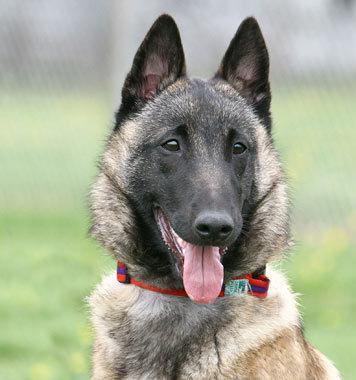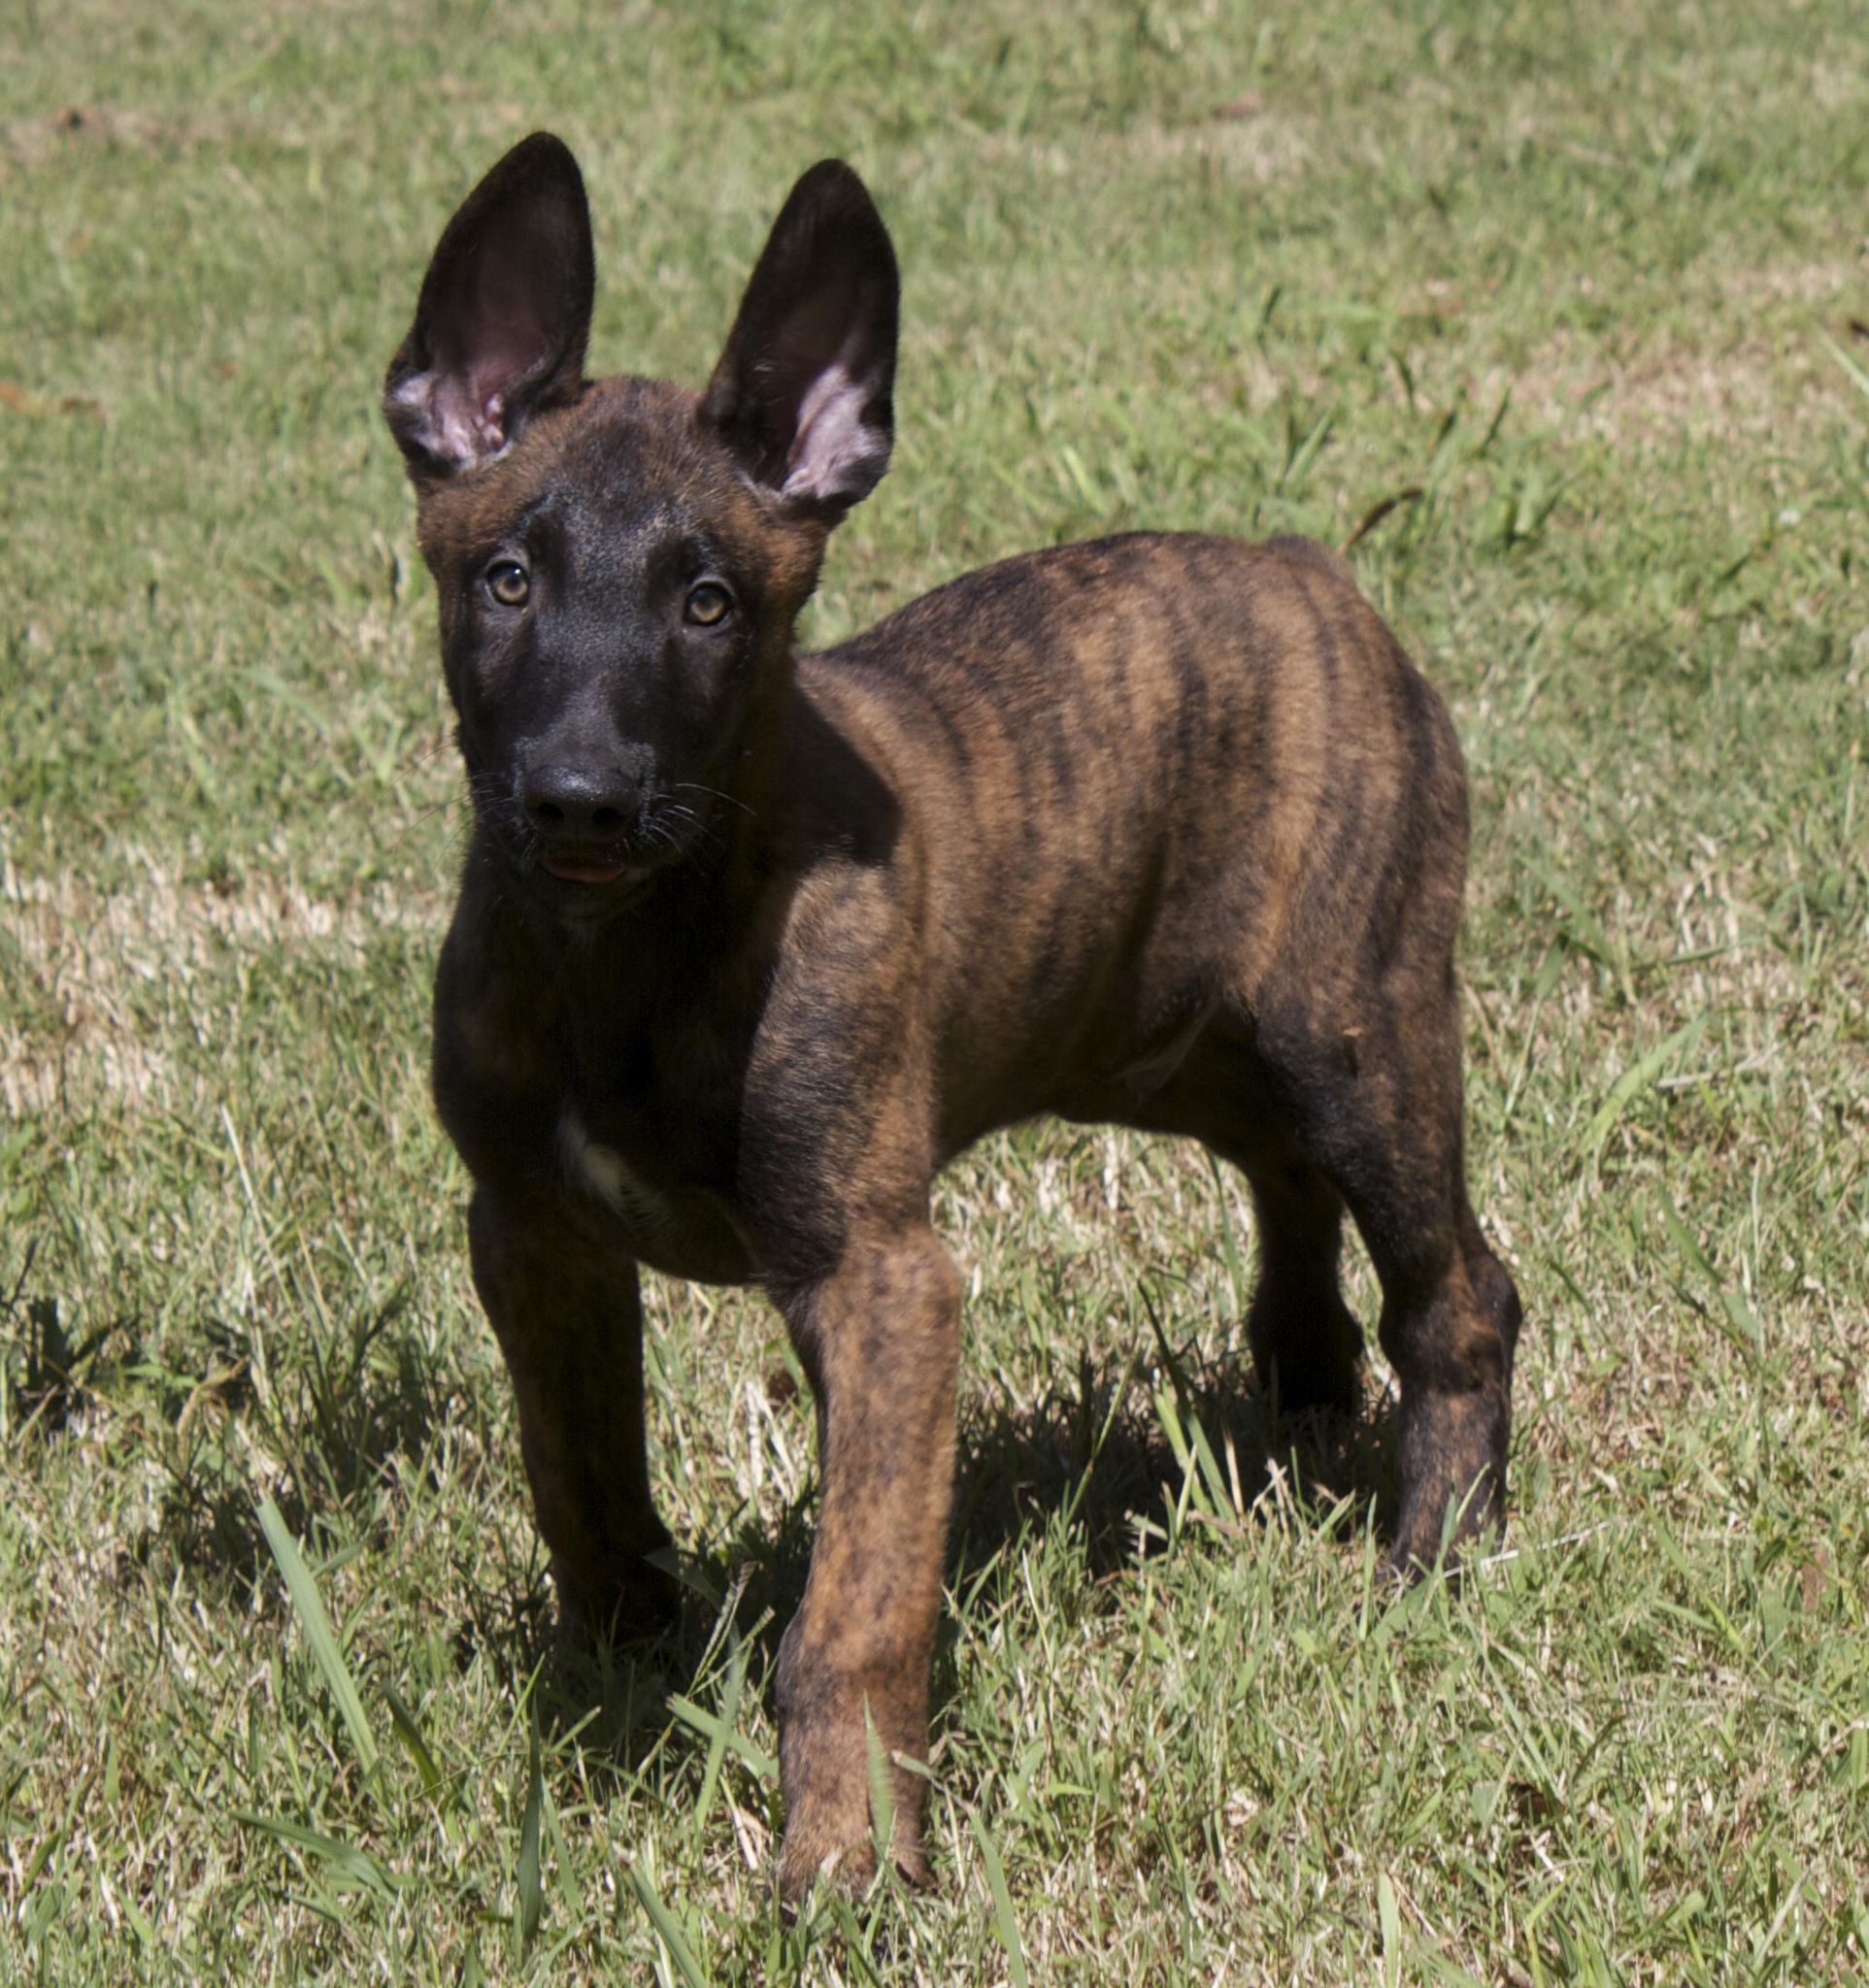The first image is the image on the left, the second image is the image on the right. For the images displayed, is the sentence "At least one dog has a red collar." factually correct? Answer yes or no. Yes. 